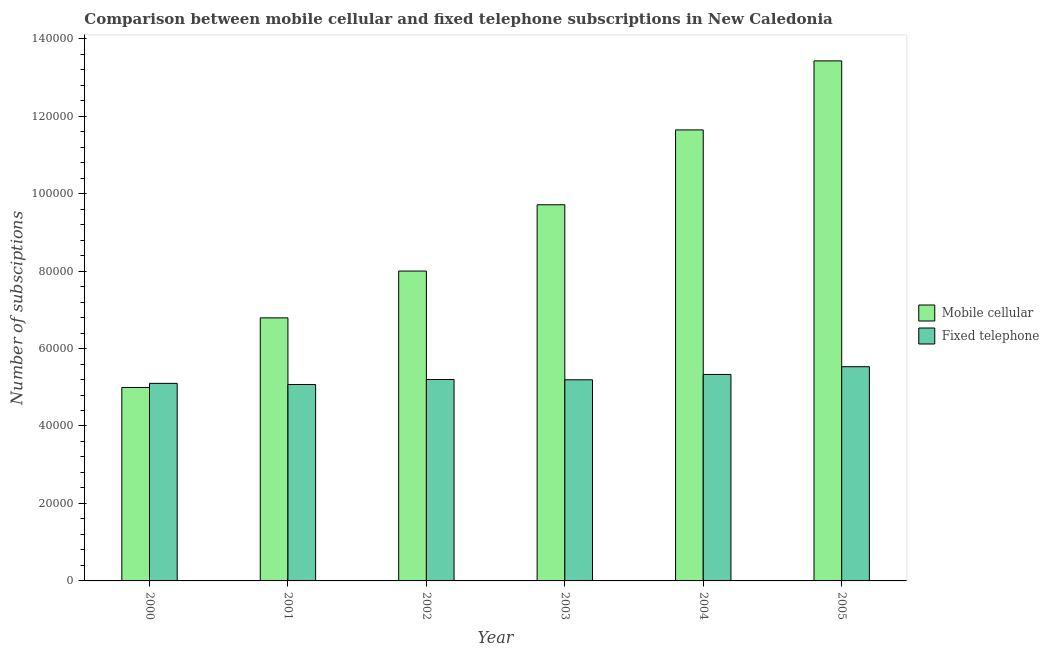Are the number of bars per tick equal to the number of legend labels?
Provide a short and direct response. Yes. Are the number of bars on each tick of the X-axis equal?
Keep it short and to the point. Yes. What is the label of the 3rd group of bars from the left?
Provide a succinct answer. 2002. What is the number of mobile cellular subscriptions in 2003?
Provide a succinct answer. 9.71e+04. Across all years, what is the maximum number of mobile cellular subscriptions?
Offer a very short reply. 1.34e+05. Across all years, what is the minimum number of fixed telephone subscriptions?
Give a very brief answer. 5.07e+04. What is the total number of fixed telephone subscriptions in the graph?
Provide a short and direct response. 3.14e+05. What is the difference between the number of fixed telephone subscriptions in 2003 and that in 2004?
Give a very brief answer. -1378. What is the average number of fixed telephone subscriptions per year?
Provide a succinct answer. 5.24e+04. In the year 2000, what is the difference between the number of fixed telephone subscriptions and number of mobile cellular subscriptions?
Your answer should be compact. 0. In how many years, is the number of mobile cellular subscriptions greater than 112000?
Make the answer very short. 2. What is the ratio of the number of fixed telephone subscriptions in 2000 to that in 2005?
Offer a terse response. 0.92. Is the number of mobile cellular subscriptions in 2003 less than that in 2004?
Your answer should be very brief. Yes. Is the difference between the number of mobile cellular subscriptions in 2001 and 2004 greater than the difference between the number of fixed telephone subscriptions in 2001 and 2004?
Your response must be concise. No. What is the difference between the highest and the second highest number of fixed telephone subscriptions?
Give a very brief answer. 2004. What is the difference between the highest and the lowest number of mobile cellular subscriptions?
Your answer should be very brief. 8.43e+04. Is the sum of the number of mobile cellular subscriptions in 2000 and 2002 greater than the maximum number of fixed telephone subscriptions across all years?
Ensure brevity in your answer.  No. What does the 2nd bar from the left in 2002 represents?
Ensure brevity in your answer.  Fixed telephone. What does the 1st bar from the right in 2004 represents?
Offer a terse response. Fixed telephone. What is the difference between two consecutive major ticks on the Y-axis?
Offer a very short reply. 2.00e+04. Are the values on the major ticks of Y-axis written in scientific E-notation?
Offer a very short reply. No. Does the graph contain grids?
Ensure brevity in your answer.  No. Where does the legend appear in the graph?
Provide a short and direct response. Center right. What is the title of the graph?
Your response must be concise. Comparison between mobile cellular and fixed telephone subscriptions in New Caledonia. What is the label or title of the X-axis?
Provide a succinct answer. Year. What is the label or title of the Y-axis?
Give a very brief answer. Number of subsciptions. What is the Number of subsciptions of Mobile cellular in 2000?
Keep it short and to the point. 4.99e+04. What is the Number of subsciptions in Fixed telephone in 2000?
Your response must be concise. 5.10e+04. What is the Number of subsciptions of Mobile cellular in 2001?
Ensure brevity in your answer.  6.79e+04. What is the Number of subsciptions in Fixed telephone in 2001?
Provide a short and direct response. 5.07e+04. What is the Number of subsciptions in Mobile cellular in 2002?
Your response must be concise. 8.00e+04. What is the Number of subsciptions in Fixed telephone in 2002?
Ensure brevity in your answer.  5.20e+04. What is the Number of subsciptions in Mobile cellular in 2003?
Your answer should be very brief. 9.71e+04. What is the Number of subsciptions in Fixed telephone in 2003?
Give a very brief answer. 5.19e+04. What is the Number of subsciptions in Mobile cellular in 2004?
Make the answer very short. 1.16e+05. What is the Number of subsciptions in Fixed telephone in 2004?
Make the answer very short. 5.33e+04. What is the Number of subsciptions of Mobile cellular in 2005?
Ensure brevity in your answer.  1.34e+05. What is the Number of subsciptions in Fixed telephone in 2005?
Make the answer very short. 5.53e+04. Across all years, what is the maximum Number of subsciptions of Mobile cellular?
Offer a terse response. 1.34e+05. Across all years, what is the maximum Number of subsciptions of Fixed telephone?
Keep it short and to the point. 5.53e+04. Across all years, what is the minimum Number of subsciptions of Mobile cellular?
Provide a short and direct response. 4.99e+04. Across all years, what is the minimum Number of subsciptions in Fixed telephone?
Provide a succinct answer. 5.07e+04. What is the total Number of subsciptions of Mobile cellular in the graph?
Ensure brevity in your answer.  5.46e+05. What is the total Number of subsciptions of Fixed telephone in the graph?
Make the answer very short. 3.14e+05. What is the difference between the Number of subsciptions in Mobile cellular in 2000 and that in 2001?
Keep it short and to the point. -1.80e+04. What is the difference between the Number of subsciptions of Fixed telephone in 2000 and that in 2001?
Your response must be concise. 296. What is the difference between the Number of subsciptions of Mobile cellular in 2000 and that in 2002?
Make the answer very short. -3.01e+04. What is the difference between the Number of subsciptions of Fixed telephone in 2000 and that in 2002?
Ensure brevity in your answer.  -995. What is the difference between the Number of subsciptions of Mobile cellular in 2000 and that in 2003?
Your answer should be very brief. -4.72e+04. What is the difference between the Number of subsciptions of Fixed telephone in 2000 and that in 2003?
Your response must be concise. -923. What is the difference between the Number of subsciptions in Mobile cellular in 2000 and that in 2004?
Provide a succinct answer. -6.65e+04. What is the difference between the Number of subsciptions of Fixed telephone in 2000 and that in 2004?
Keep it short and to the point. -2301. What is the difference between the Number of subsciptions in Mobile cellular in 2000 and that in 2005?
Offer a very short reply. -8.43e+04. What is the difference between the Number of subsciptions of Fixed telephone in 2000 and that in 2005?
Provide a short and direct response. -4305. What is the difference between the Number of subsciptions of Mobile cellular in 2001 and that in 2002?
Offer a terse response. -1.21e+04. What is the difference between the Number of subsciptions of Fixed telephone in 2001 and that in 2002?
Your response must be concise. -1291. What is the difference between the Number of subsciptions of Mobile cellular in 2001 and that in 2003?
Provide a short and direct response. -2.92e+04. What is the difference between the Number of subsciptions in Fixed telephone in 2001 and that in 2003?
Provide a succinct answer. -1219. What is the difference between the Number of subsciptions in Mobile cellular in 2001 and that in 2004?
Keep it short and to the point. -4.85e+04. What is the difference between the Number of subsciptions of Fixed telephone in 2001 and that in 2004?
Offer a terse response. -2597. What is the difference between the Number of subsciptions of Mobile cellular in 2001 and that in 2005?
Provide a short and direct response. -6.63e+04. What is the difference between the Number of subsciptions in Fixed telephone in 2001 and that in 2005?
Your response must be concise. -4601. What is the difference between the Number of subsciptions of Mobile cellular in 2002 and that in 2003?
Your answer should be compact. -1.71e+04. What is the difference between the Number of subsciptions in Fixed telephone in 2002 and that in 2003?
Make the answer very short. 72. What is the difference between the Number of subsciptions in Mobile cellular in 2002 and that in 2004?
Keep it short and to the point. -3.64e+04. What is the difference between the Number of subsciptions of Fixed telephone in 2002 and that in 2004?
Offer a very short reply. -1306. What is the difference between the Number of subsciptions in Mobile cellular in 2002 and that in 2005?
Ensure brevity in your answer.  -5.43e+04. What is the difference between the Number of subsciptions of Fixed telephone in 2002 and that in 2005?
Make the answer very short. -3310. What is the difference between the Number of subsciptions in Mobile cellular in 2003 and that in 2004?
Your answer should be compact. -1.93e+04. What is the difference between the Number of subsciptions in Fixed telephone in 2003 and that in 2004?
Provide a succinct answer. -1378. What is the difference between the Number of subsciptions in Mobile cellular in 2003 and that in 2005?
Give a very brief answer. -3.72e+04. What is the difference between the Number of subsciptions in Fixed telephone in 2003 and that in 2005?
Make the answer very short. -3382. What is the difference between the Number of subsciptions of Mobile cellular in 2004 and that in 2005?
Make the answer very short. -1.78e+04. What is the difference between the Number of subsciptions of Fixed telephone in 2004 and that in 2005?
Offer a very short reply. -2004. What is the difference between the Number of subsciptions of Mobile cellular in 2000 and the Number of subsciptions of Fixed telephone in 2001?
Offer a terse response. -761. What is the difference between the Number of subsciptions in Mobile cellular in 2000 and the Number of subsciptions in Fixed telephone in 2002?
Make the answer very short. -2052. What is the difference between the Number of subsciptions of Mobile cellular in 2000 and the Number of subsciptions of Fixed telephone in 2003?
Ensure brevity in your answer.  -1980. What is the difference between the Number of subsciptions in Mobile cellular in 2000 and the Number of subsciptions in Fixed telephone in 2004?
Your answer should be compact. -3358. What is the difference between the Number of subsciptions in Mobile cellular in 2000 and the Number of subsciptions in Fixed telephone in 2005?
Provide a succinct answer. -5362. What is the difference between the Number of subsciptions in Mobile cellular in 2001 and the Number of subsciptions in Fixed telephone in 2002?
Offer a terse response. 1.59e+04. What is the difference between the Number of subsciptions of Mobile cellular in 2001 and the Number of subsciptions of Fixed telephone in 2003?
Provide a short and direct response. 1.60e+04. What is the difference between the Number of subsciptions of Mobile cellular in 2001 and the Number of subsciptions of Fixed telephone in 2004?
Offer a very short reply. 1.46e+04. What is the difference between the Number of subsciptions in Mobile cellular in 2001 and the Number of subsciptions in Fixed telephone in 2005?
Provide a short and direct response. 1.26e+04. What is the difference between the Number of subsciptions in Mobile cellular in 2002 and the Number of subsciptions in Fixed telephone in 2003?
Your answer should be compact. 2.81e+04. What is the difference between the Number of subsciptions in Mobile cellular in 2002 and the Number of subsciptions in Fixed telephone in 2004?
Keep it short and to the point. 2.67e+04. What is the difference between the Number of subsciptions of Mobile cellular in 2002 and the Number of subsciptions of Fixed telephone in 2005?
Your answer should be compact. 2.47e+04. What is the difference between the Number of subsciptions in Mobile cellular in 2003 and the Number of subsciptions in Fixed telephone in 2004?
Your response must be concise. 4.38e+04. What is the difference between the Number of subsciptions in Mobile cellular in 2003 and the Number of subsciptions in Fixed telephone in 2005?
Offer a very short reply. 4.18e+04. What is the difference between the Number of subsciptions in Mobile cellular in 2004 and the Number of subsciptions in Fixed telephone in 2005?
Offer a very short reply. 6.11e+04. What is the average Number of subsciptions of Mobile cellular per year?
Keep it short and to the point. 9.09e+04. What is the average Number of subsciptions of Fixed telephone per year?
Your response must be concise. 5.24e+04. In the year 2000, what is the difference between the Number of subsciptions in Mobile cellular and Number of subsciptions in Fixed telephone?
Your answer should be compact. -1057. In the year 2001, what is the difference between the Number of subsciptions in Mobile cellular and Number of subsciptions in Fixed telephone?
Your response must be concise. 1.72e+04. In the year 2002, what is the difference between the Number of subsciptions of Mobile cellular and Number of subsciptions of Fixed telephone?
Keep it short and to the point. 2.80e+04. In the year 2003, what is the difference between the Number of subsciptions of Mobile cellular and Number of subsciptions of Fixed telephone?
Offer a very short reply. 4.52e+04. In the year 2004, what is the difference between the Number of subsciptions in Mobile cellular and Number of subsciptions in Fixed telephone?
Offer a very short reply. 6.31e+04. In the year 2005, what is the difference between the Number of subsciptions in Mobile cellular and Number of subsciptions in Fixed telephone?
Make the answer very short. 7.90e+04. What is the ratio of the Number of subsciptions in Mobile cellular in 2000 to that in 2001?
Keep it short and to the point. 0.74. What is the ratio of the Number of subsciptions in Mobile cellular in 2000 to that in 2002?
Make the answer very short. 0.62. What is the ratio of the Number of subsciptions in Fixed telephone in 2000 to that in 2002?
Offer a terse response. 0.98. What is the ratio of the Number of subsciptions in Mobile cellular in 2000 to that in 2003?
Provide a short and direct response. 0.51. What is the ratio of the Number of subsciptions of Fixed telephone in 2000 to that in 2003?
Provide a short and direct response. 0.98. What is the ratio of the Number of subsciptions of Mobile cellular in 2000 to that in 2004?
Your answer should be compact. 0.43. What is the ratio of the Number of subsciptions of Fixed telephone in 2000 to that in 2004?
Ensure brevity in your answer.  0.96. What is the ratio of the Number of subsciptions of Mobile cellular in 2000 to that in 2005?
Give a very brief answer. 0.37. What is the ratio of the Number of subsciptions in Fixed telephone in 2000 to that in 2005?
Your answer should be very brief. 0.92. What is the ratio of the Number of subsciptions of Mobile cellular in 2001 to that in 2002?
Give a very brief answer. 0.85. What is the ratio of the Number of subsciptions of Fixed telephone in 2001 to that in 2002?
Offer a terse response. 0.98. What is the ratio of the Number of subsciptions in Mobile cellular in 2001 to that in 2003?
Give a very brief answer. 0.7. What is the ratio of the Number of subsciptions in Fixed telephone in 2001 to that in 2003?
Ensure brevity in your answer.  0.98. What is the ratio of the Number of subsciptions of Mobile cellular in 2001 to that in 2004?
Your answer should be compact. 0.58. What is the ratio of the Number of subsciptions in Fixed telephone in 2001 to that in 2004?
Make the answer very short. 0.95. What is the ratio of the Number of subsciptions of Mobile cellular in 2001 to that in 2005?
Make the answer very short. 0.51. What is the ratio of the Number of subsciptions in Fixed telephone in 2001 to that in 2005?
Provide a short and direct response. 0.92. What is the ratio of the Number of subsciptions in Mobile cellular in 2002 to that in 2003?
Offer a very short reply. 0.82. What is the ratio of the Number of subsciptions of Fixed telephone in 2002 to that in 2003?
Offer a terse response. 1. What is the ratio of the Number of subsciptions in Mobile cellular in 2002 to that in 2004?
Offer a very short reply. 0.69. What is the ratio of the Number of subsciptions in Fixed telephone in 2002 to that in 2004?
Offer a very short reply. 0.98. What is the ratio of the Number of subsciptions of Mobile cellular in 2002 to that in 2005?
Your answer should be compact. 0.6. What is the ratio of the Number of subsciptions of Fixed telephone in 2002 to that in 2005?
Your answer should be very brief. 0.94. What is the ratio of the Number of subsciptions of Mobile cellular in 2003 to that in 2004?
Make the answer very short. 0.83. What is the ratio of the Number of subsciptions in Fixed telephone in 2003 to that in 2004?
Your answer should be very brief. 0.97. What is the ratio of the Number of subsciptions in Mobile cellular in 2003 to that in 2005?
Keep it short and to the point. 0.72. What is the ratio of the Number of subsciptions in Fixed telephone in 2003 to that in 2005?
Your answer should be very brief. 0.94. What is the ratio of the Number of subsciptions of Mobile cellular in 2004 to that in 2005?
Your response must be concise. 0.87. What is the ratio of the Number of subsciptions of Fixed telephone in 2004 to that in 2005?
Give a very brief answer. 0.96. What is the difference between the highest and the second highest Number of subsciptions of Mobile cellular?
Provide a succinct answer. 1.78e+04. What is the difference between the highest and the second highest Number of subsciptions in Fixed telephone?
Make the answer very short. 2004. What is the difference between the highest and the lowest Number of subsciptions in Mobile cellular?
Your answer should be very brief. 8.43e+04. What is the difference between the highest and the lowest Number of subsciptions of Fixed telephone?
Offer a very short reply. 4601. 